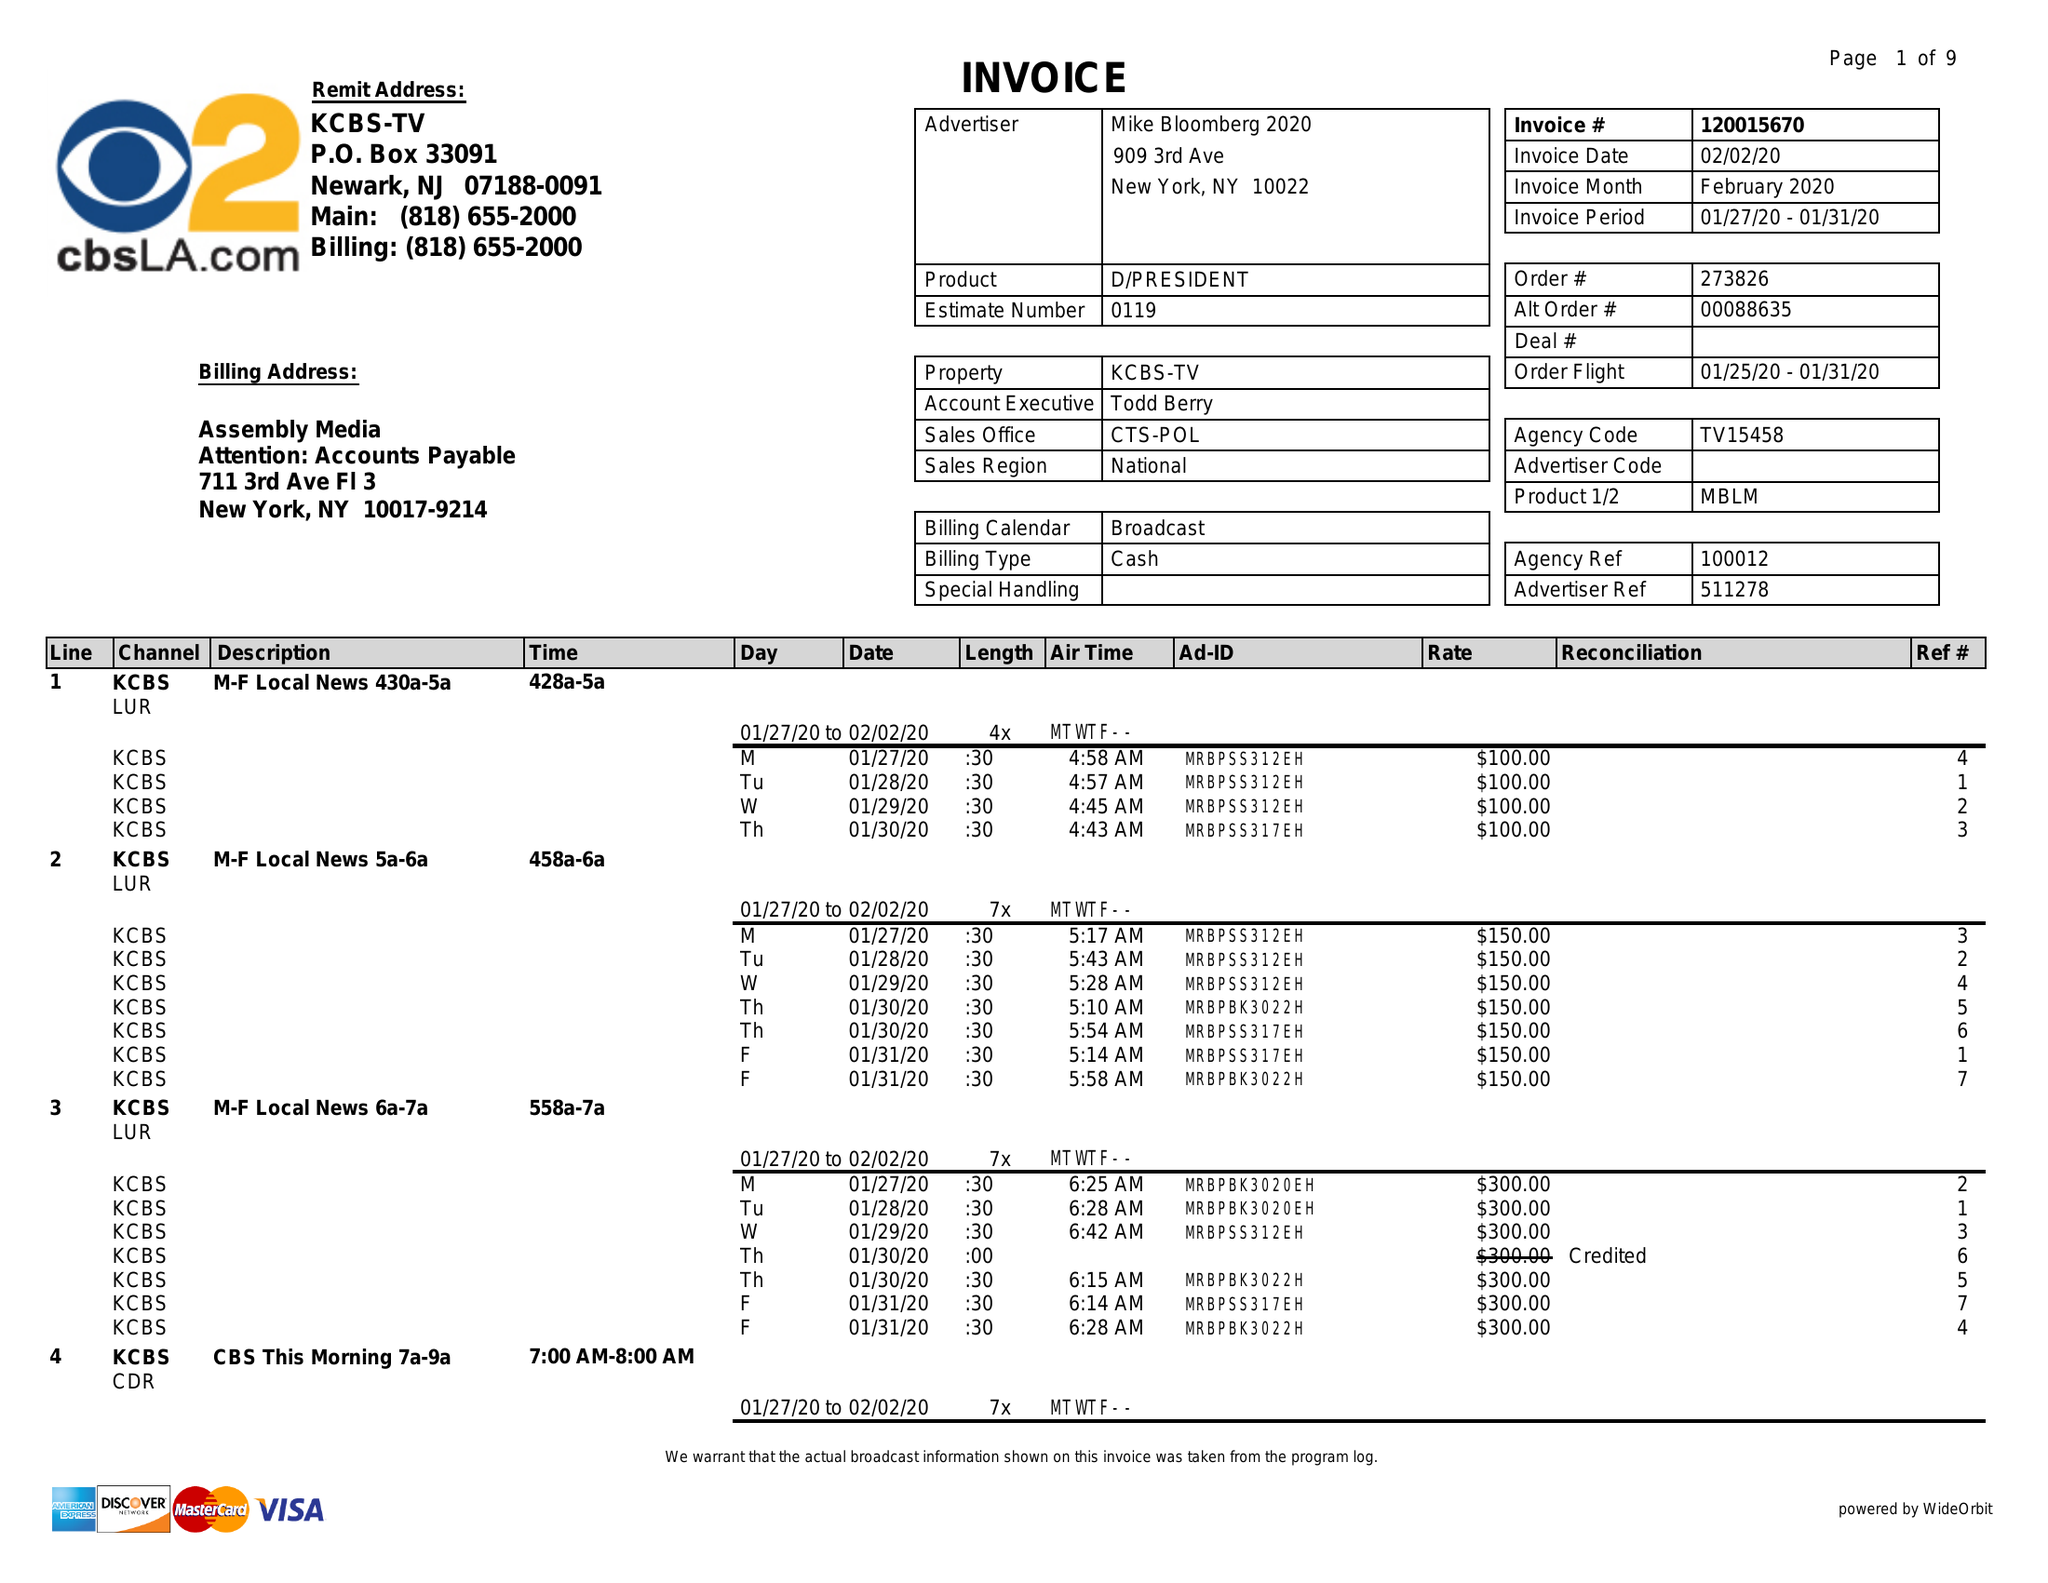What is the value for the flight_to?
Answer the question using a single word or phrase. 01/31/20 